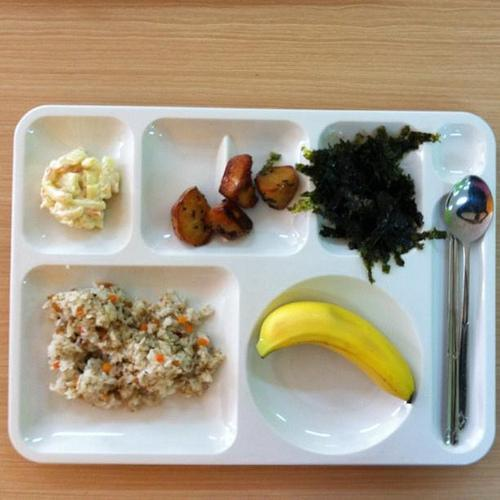Question: what is the color of the banana?
Choices:
A. Green.
B. Brown.
C. Black.
D. Yellow.
Answer with the letter. Answer: D Question: how many spoons?
Choices:
A. 1.
B. 3.
C. 5.
D. 2.
Answer with the letter. Answer: D 